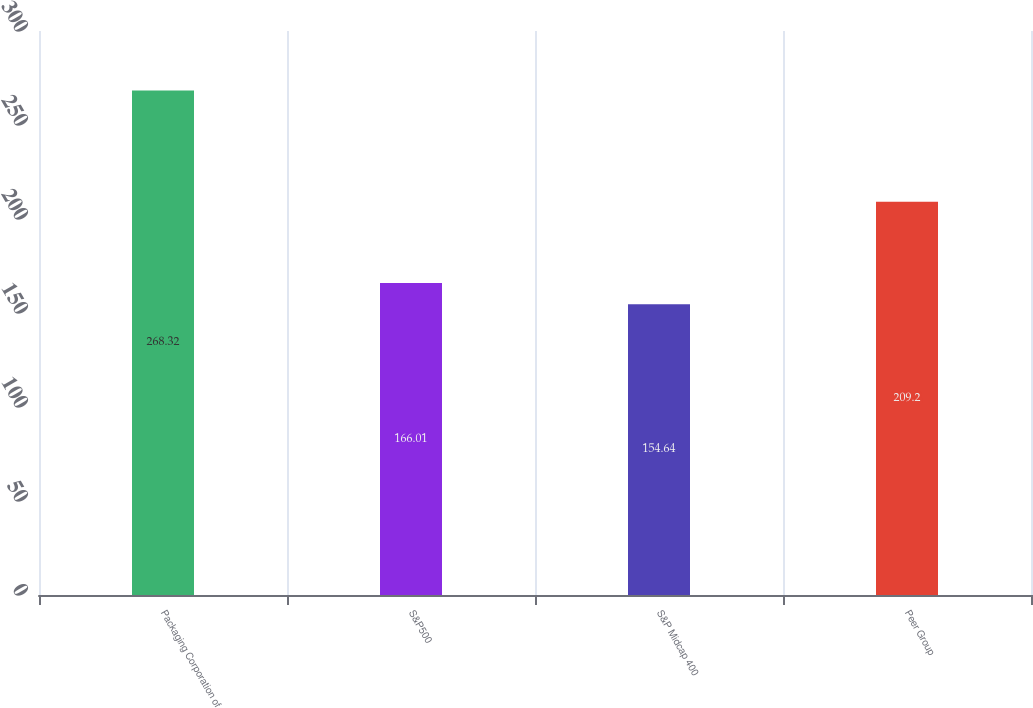<chart> <loc_0><loc_0><loc_500><loc_500><bar_chart><fcel>Packaging Corporation of<fcel>S&P500<fcel>S&P Midcap 400<fcel>Peer Group<nl><fcel>268.32<fcel>166.01<fcel>154.64<fcel>209.2<nl></chart> 